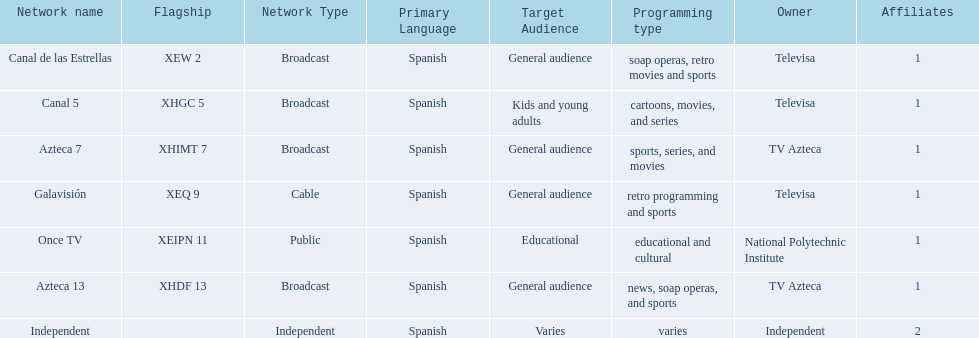Could you parse the entire table as a dict? {'header': ['Network name', 'Flagship', 'Network Type', 'Primary Language', 'Target Audience', 'Programming type', 'Owner', 'Affiliates'], 'rows': [['Canal de las Estrellas', 'XEW 2', 'Broadcast', 'Spanish', 'General audience', 'soap operas, retro movies and sports', 'Televisa', '1'], ['Canal 5', 'XHGC 5', 'Broadcast', 'Spanish', 'Kids and young adults', 'cartoons, movies, and series', 'Televisa', '1'], ['Azteca 7', 'XHIMT 7', 'Broadcast', 'Spanish', 'General audience', 'sports, series, and movies', 'TV Azteca', '1'], ['Galavisión', 'XEQ 9', 'Cable', 'Spanish', 'General audience', 'retro programming and sports', 'Televisa', '1'], ['Once TV', 'XEIPN 11', 'Public', 'Spanish', 'Educational', 'educational and cultural', 'National Polytechnic Institute', '1'], ['Azteca 13', 'XHDF 13', 'Broadcast', 'Spanish', 'General audience', 'news, soap operas, and sports', 'TV Azteca', '1'], ['Independent', '', 'Independent', 'Spanish', 'Varies', 'varies', 'Independent', '2']]} How many networks does tv azteca own? 2. 